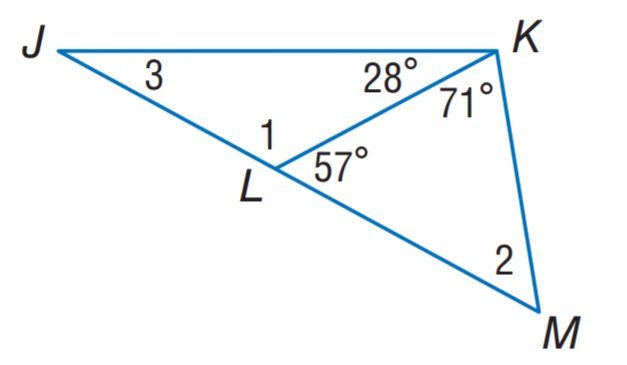Answer the mathemtical geometry problem and directly provide the correct option letter.
Question: Find m \angle 1.
Choices: A: 52 B: 123 C: 128 D: 151 B 